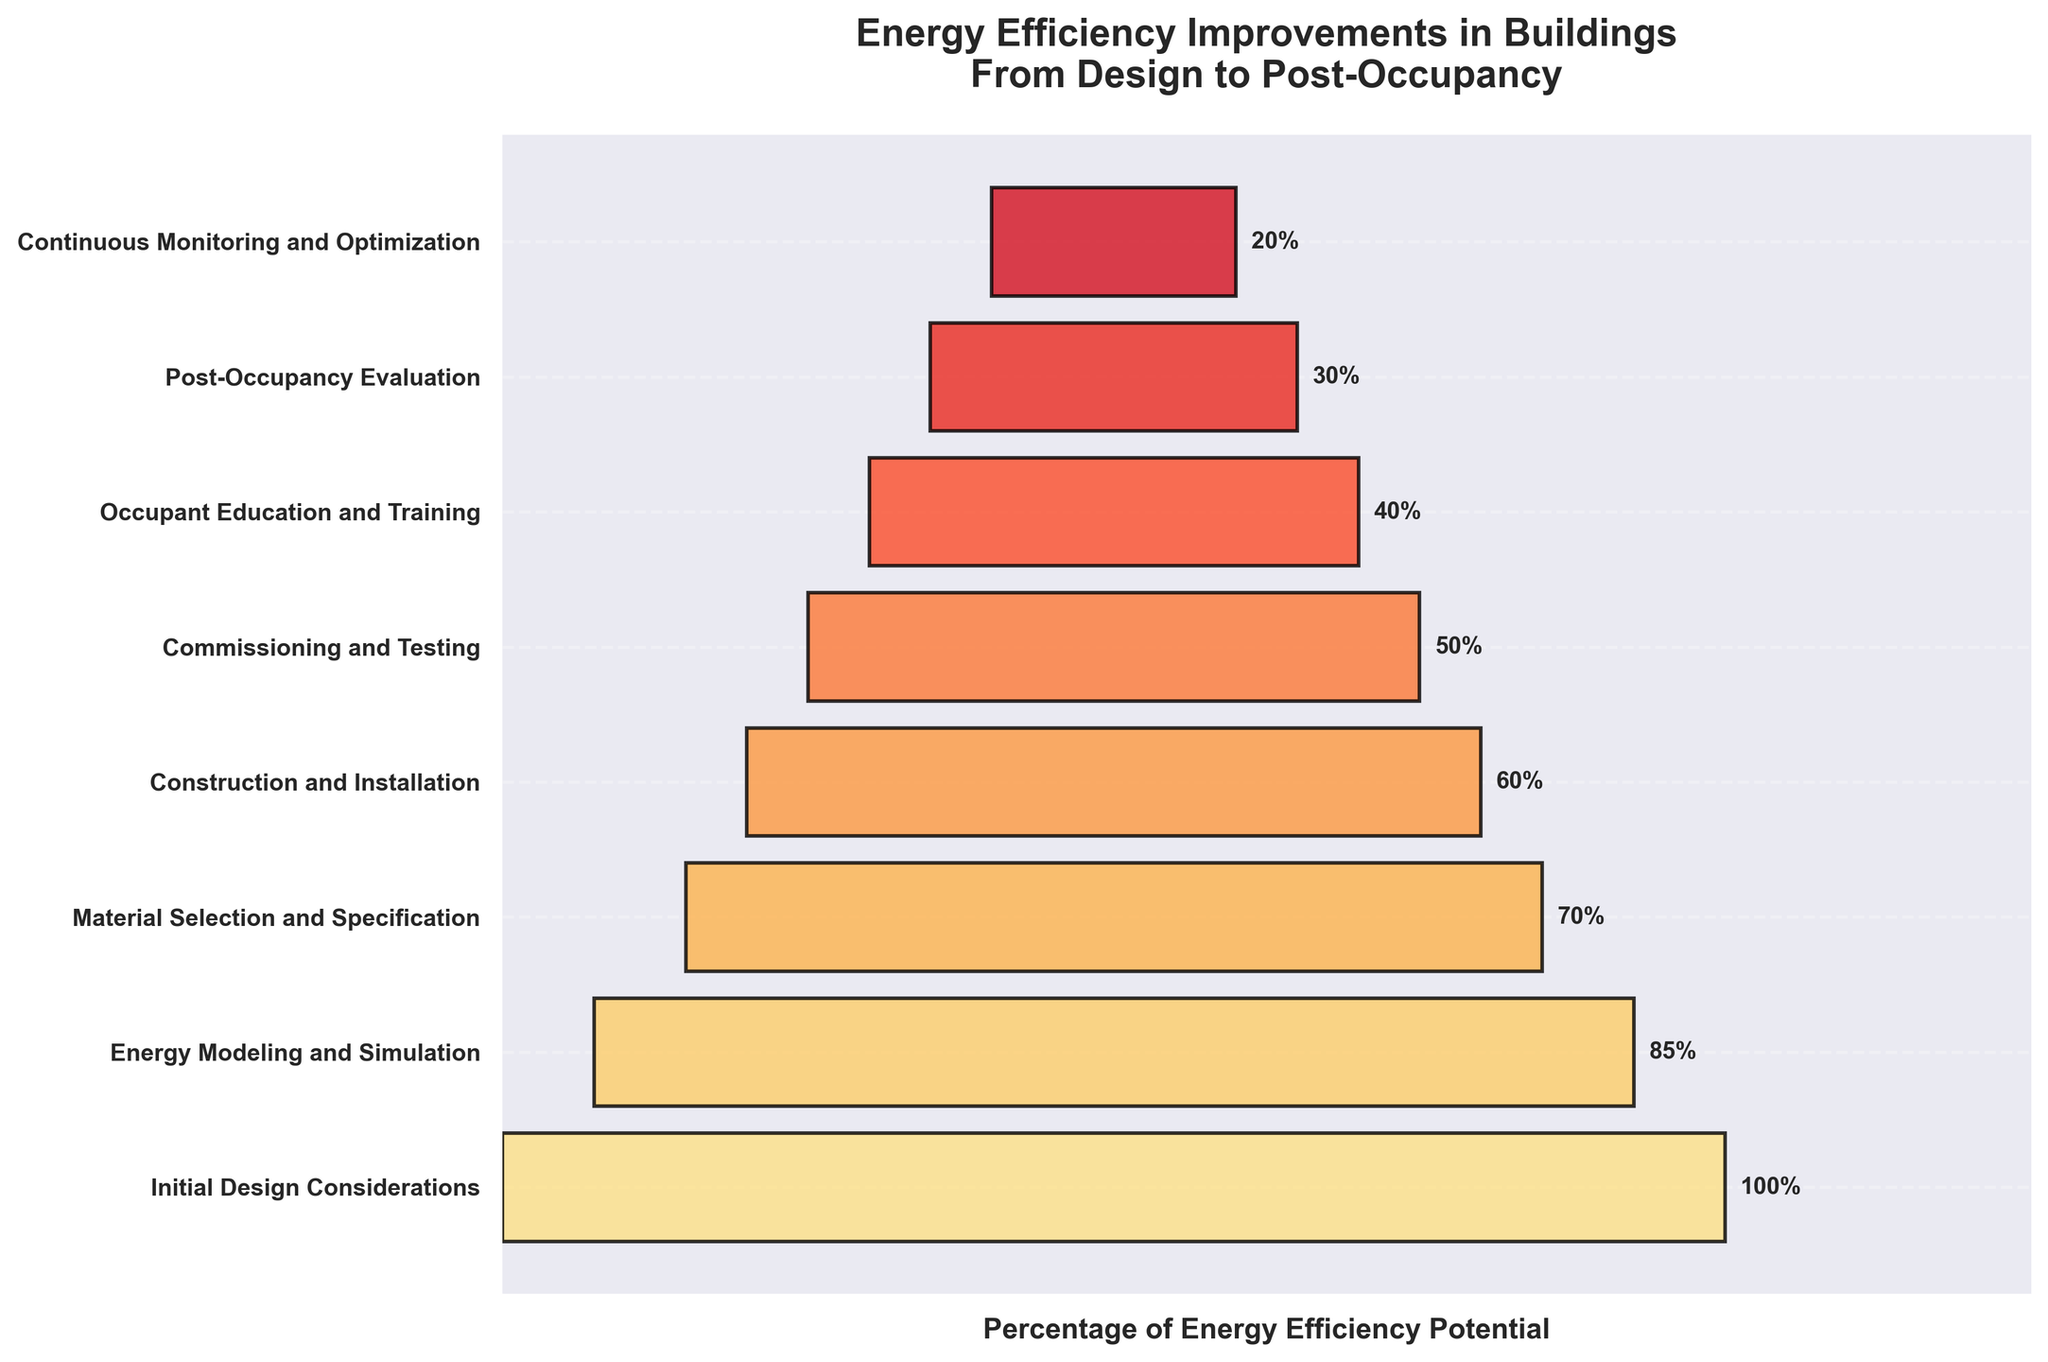What is the title of the chart? The title is located at the top of the chart in bold, indicating the main subject of the figure.
Answer: Energy Efficiency Improvements in Buildings From Design to Post-Occupancy How many stages are shown in the chart? By counting the labeled entries along the y-axis, we can see the number of different stages displayed.
Answer: 8 What is the percentage of energy efficiency potential at the 'Energy Modeling and Simulation' stage? We can find this value directly next to the 'Energy Modeling and Simulation' stage in the funnel chart.
Answer: 85% By how much does the energy efficiency potential drop between 'Material Selection and Specification' and 'Commissioning and Testing'? Subtract the percentage at 'Commissioning and Testing' stage from that at 'Material Selection and Specification' stage: 70% - 50%
Answer: 20% Which stage shows the lowest percentage of energy efficiency potential? The stage with the smallest bar width and the lowest percentage label represents the lowest stage.
Answer: Continuous Monitoring and Optimization Which two stages have the greatest drop in energy efficiency potential between them? Identify the stages with the greatest difference in their percentage values. In this case, it's between 'Initial Design Considerations' and 'Energy Modeling and Simulation': 100% - 85%
Answer: Initial Design Considerations and Energy Modeling and Simulation Calculate the average energy efficiency potential across all stages. Sum up all the percentages and divide by the number of stages: (100 + 85 + 70 + 60 + 50 + 40 + 30 + 20) / 8
Answer: 56.25% Does any stage have an energy efficiency potential of exactly half of the 'Initial Design Considerations' stage? A stage with exactly 50% (which is half of 100%) is identified as 'Commissioning and Testing'.
Answer: Yes Compare the energy efficiency potential difference between 'Construction and Installation' and 'Occupant Education and Training'. Which stage has a higher potential? By comparing the percentages: 60% (Construction and Installation) vs. 40% (Occupant Education and Training), 60% is higher.
Answer: Construction and Installation What is the total percentage drop in energy efficiency potential from the 'Initial Design Considerations' stage to the 'Continuous Monitoring and Optimization' stage? Subtract the final stage's percentage from the initial stage's percentage: 100% - 20%
Answer: 80% 